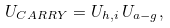Convert formula to latex. <formula><loc_0><loc_0><loc_500><loc_500>U _ { C A R R Y } = U _ { h , i } \, U _ { a - g } ,</formula> 